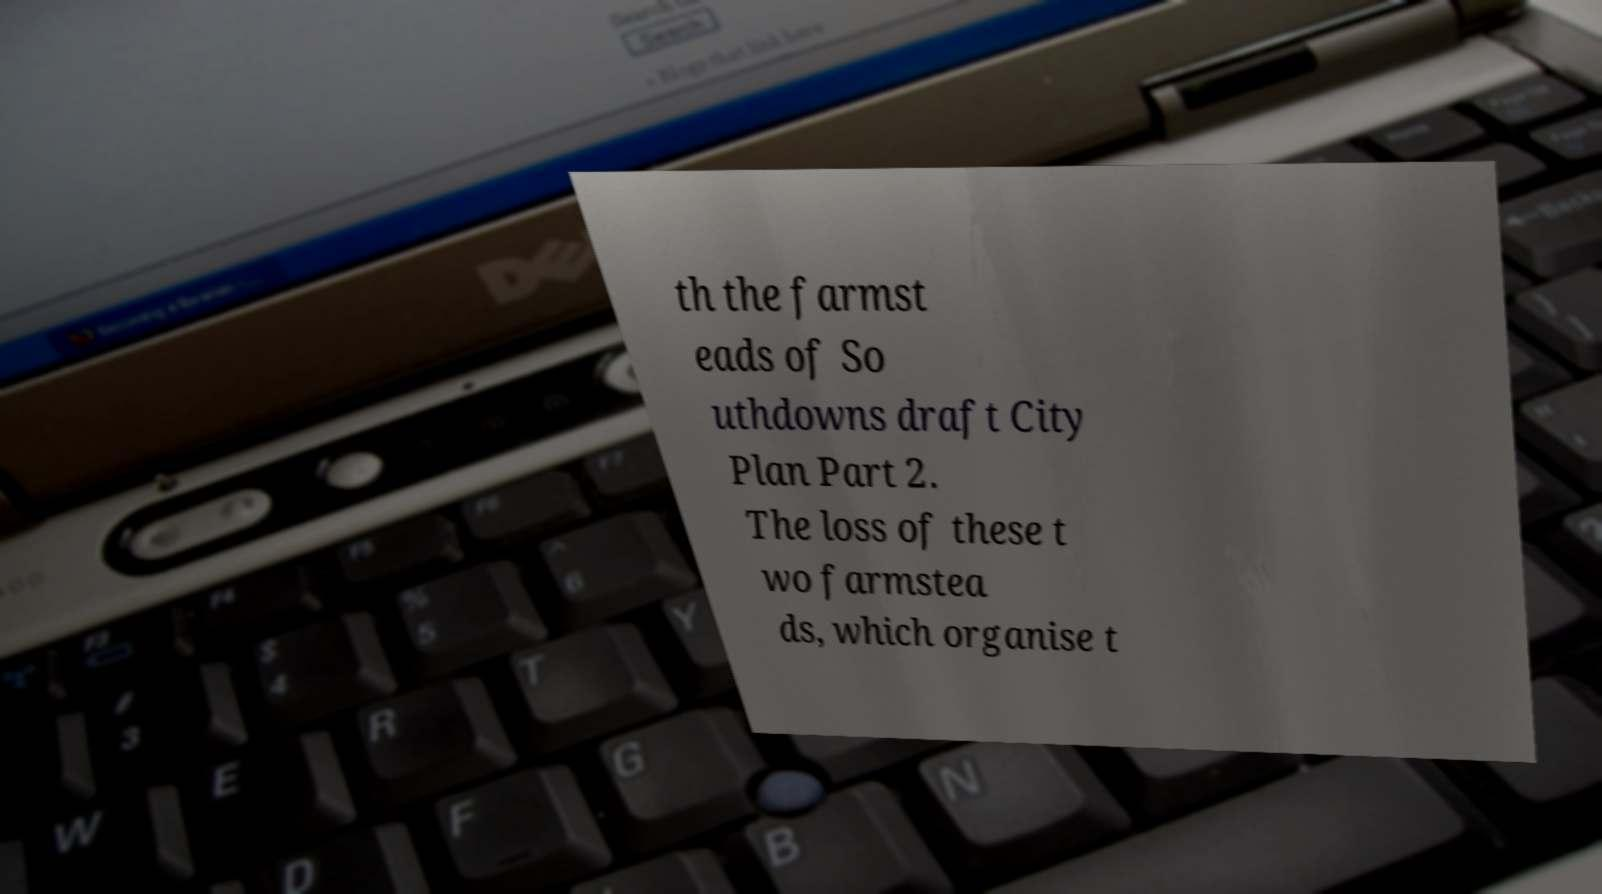Can you accurately transcribe the text from the provided image for me? th the farmst eads of So uthdowns draft City Plan Part 2. The loss of these t wo farmstea ds, which organise t 